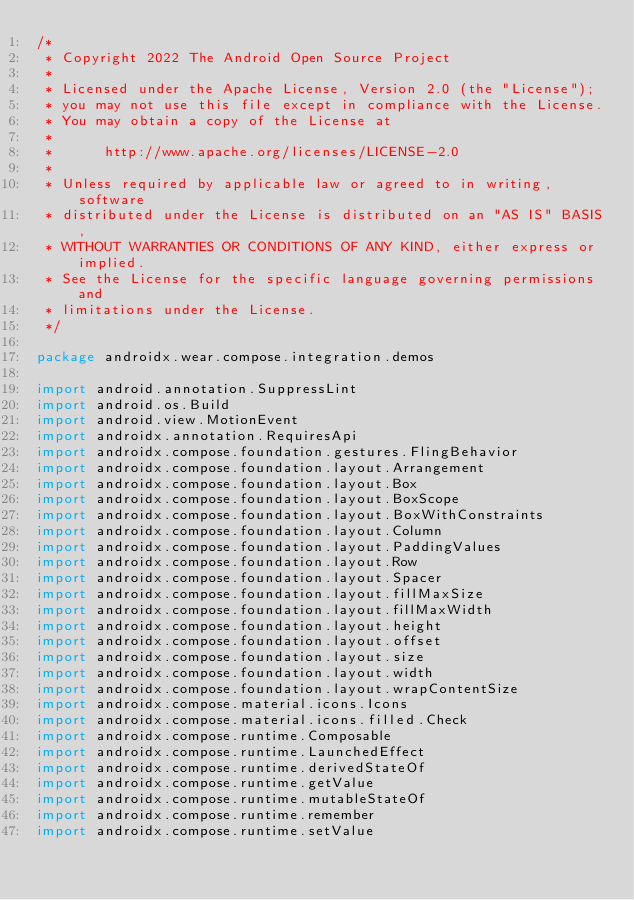Convert code to text. <code><loc_0><loc_0><loc_500><loc_500><_Kotlin_>/*
 * Copyright 2022 The Android Open Source Project
 *
 * Licensed under the Apache License, Version 2.0 (the "License");
 * you may not use this file except in compliance with the License.
 * You may obtain a copy of the License at
 *
 *      http://www.apache.org/licenses/LICENSE-2.0
 *
 * Unless required by applicable law or agreed to in writing, software
 * distributed under the License is distributed on an "AS IS" BASIS,
 * WITHOUT WARRANTIES OR CONDITIONS OF ANY KIND, either express or implied.
 * See the License for the specific language governing permissions and
 * limitations under the License.
 */

package androidx.wear.compose.integration.demos

import android.annotation.SuppressLint
import android.os.Build
import android.view.MotionEvent
import androidx.annotation.RequiresApi
import androidx.compose.foundation.gestures.FlingBehavior
import androidx.compose.foundation.layout.Arrangement
import androidx.compose.foundation.layout.Box
import androidx.compose.foundation.layout.BoxScope
import androidx.compose.foundation.layout.BoxWithConstraints
import androidx.compose.foundation.layout.Column
import androidx.compose.foundation.layout.PaddingValues
import androidx.compose.foundation.layout.Row
import androidx.compose.foundation.layout.Spacer
import androidx.compose.foundation.layout.fillMaxSize
import androidx.compose.foundation.layout.fillMaxWidth
import androidx.compose.foundation.layout.height
import androidx.compose.foundation.layout.offset
import androidx.compose.foundation.layout.size
import androidx.compose.foundation.layout.width
import androidx.compose.foundation.layout.wrapContentSize
import androidx.compose.material.icons.Icons
import androidx.compose.material.icons.filled.Check
import androidx.compose.runtime.Composable
import androidx.compose.runtime.LaunchedEffect
import androidx.compose.runtime.derivedStateOf
import androidx.compose.runtime.getValue
import androidx.compose.runtime.mutableStateOf
import androidx.compose.runtime.remember
import androidx.compose.runtime.setValue</code> 